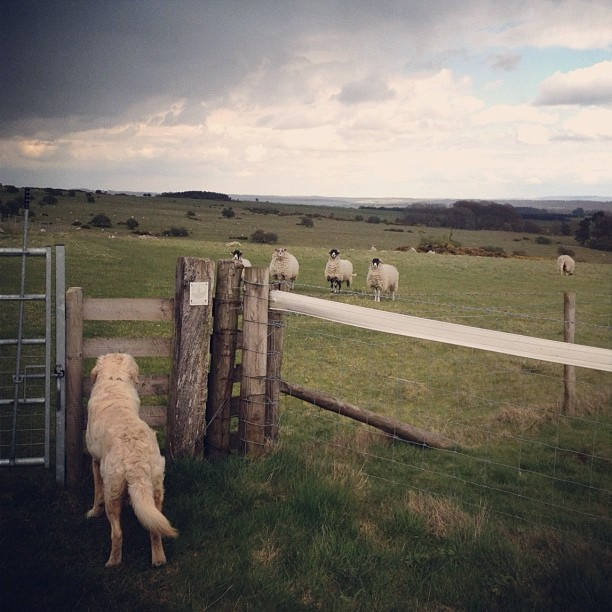Describe the objects in this image and their specific colors. I can see dog in black, tan, and gray tones, sheep in black, tan, and gray tones, sheep in black, tan, and gray tones, sheep in black, tan, and gray tones, and sheep in black, gray, and tan tones in this image. 